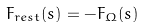Convert formula to latex. <formula><loc_0><loc_0><loc_500><loc_500>F _ { r e s t } ( s ) = - F _ { \Omega } ( s )</formula> 